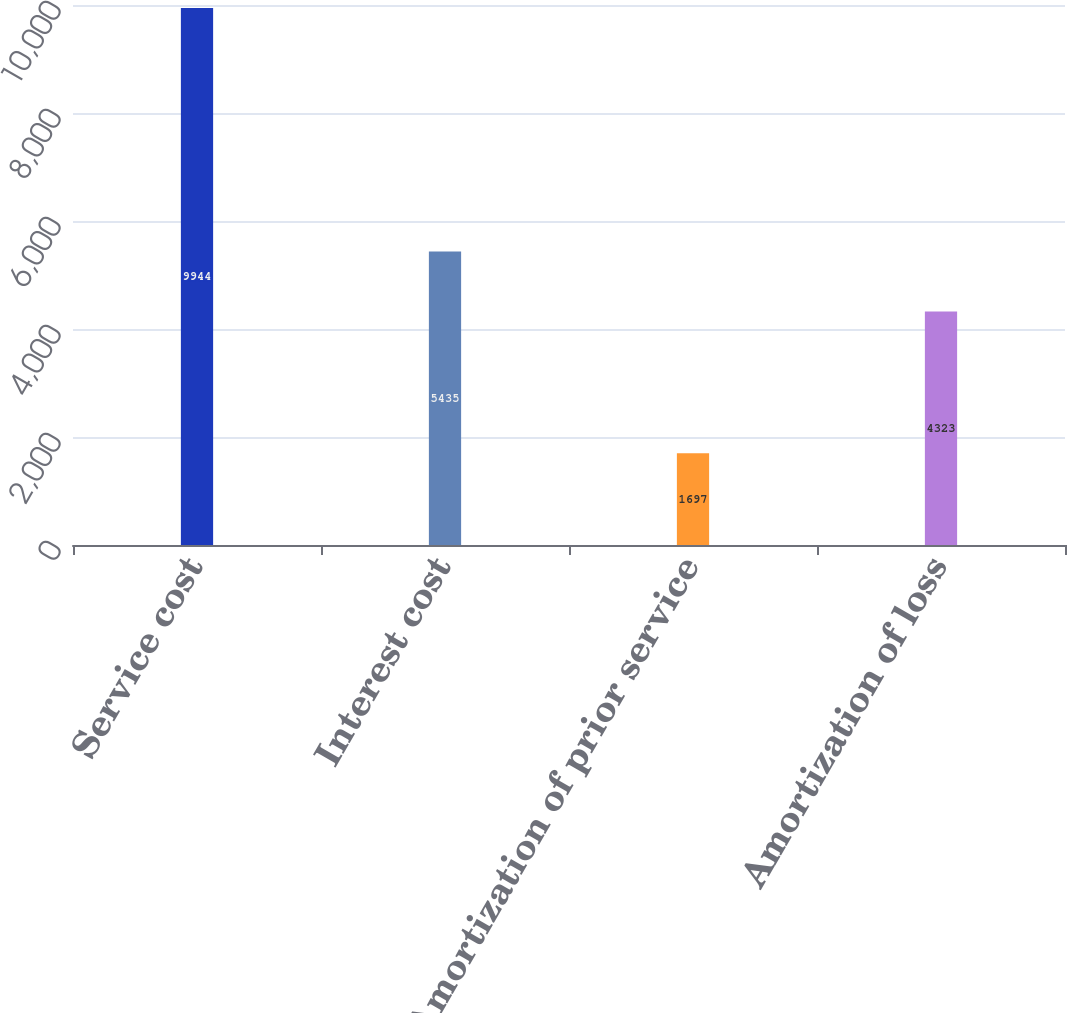Convert chart. <chart><loc_0><loc_0><loc_500><loc_500><bar_chart><fcel>Service cost<fcel>Interest cost<fcel>Amortization of prior service<fcel>Amortization of loss<nl><fcel>9944<fcel>5435<fcel>1697<fcel>4323<nl></chart> 